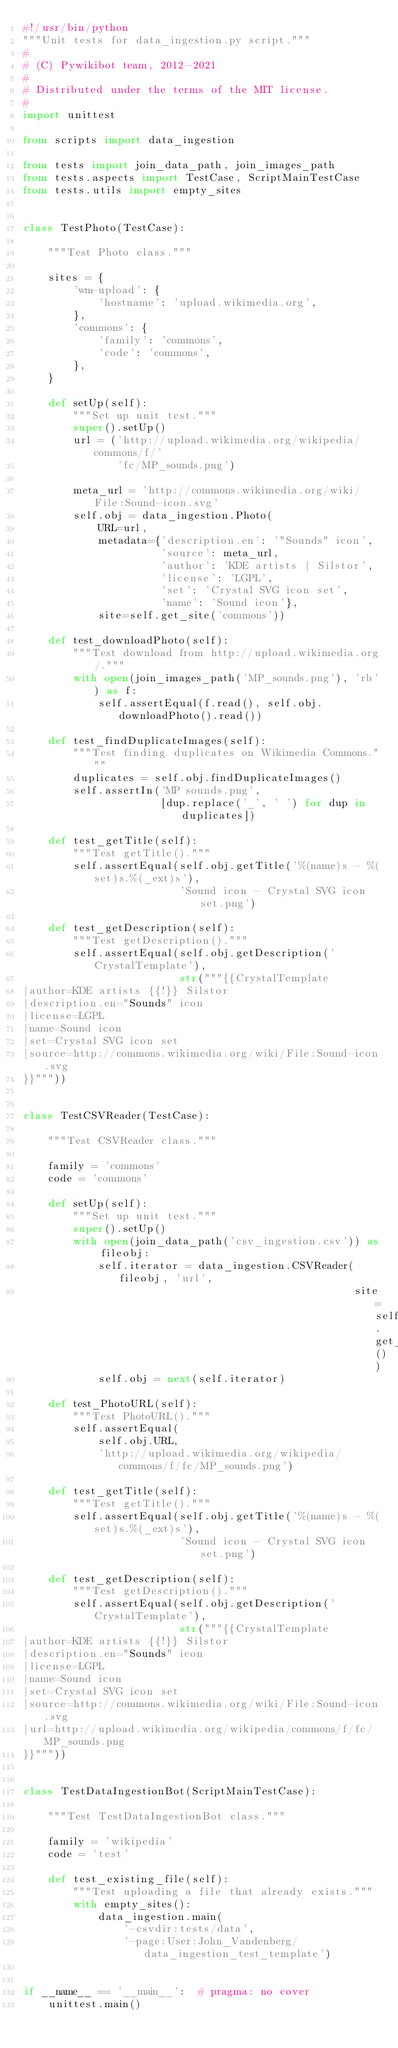Convert code to text. <code><loc_0><loc_0><loc_500><loc_500><_Python_>#!/usr/bin/python
"""Unit tests for data_ingestion.py script."""
#
# (C) Pywikibot team, 2012-2021
#
# Distributed under the terms of the MIT license.
#
import unittest

from scripts import data_ingestion

from tests import join_data_path, join_images_path
from tests.aspects import TestCase, ScriptMainTestCase
from tests.utils import empty_sites


class TestPhoto(TestCase):

    """Test Photo class."""

    sites = {
        'wm-upload': {
            'hostname': 'upload.wikimedia.org',
        },
        'commons': {
            'family': 'commons',
            'code': 'commons',
        },
    }

    def setUp(self):
        """Set up unit test."""
        super().setUp()
        url = ('http://upload.wikimedia.org/wikipedia/commons/f/'
               'fc/MP_sounds.png')

        meta_url = 'http://commons.wikimedia.org/wiki/File:Sound-icon.svg'
        self.obj = data_ingestion.Photo(
            URL=url,
            metadata={'description.en': '"Sounds" icon',
                      'source': meta_url,
                      'author': 'KDE artists | Silstor',
                      'license': 'LGPL',
                      'set': 'Crystal SVG icon set',
                      'name': 'Sound icon'},
            site=self.get_site('commons'))

    def test_downloadPhoto(self):
        """Test download from http://upload.wikimedia.org/."""
        with open(join_images_path('MP_sounds.png'), 'rb') as f:
            self.assertEqual(f.read(), self.obj.downloadPhoto().read())

    def test_findDuplicateImages(self):
        """Test finding duplicates on Wikimedia Commons."""
        duplicates = self.obj.findDuplicateImages()
        self.assertIn('MP sounds.png',
                      [dup.replace('_', ' ') for dup in duplicates])

    def test_getTitle(self):
        """Test getTitle()."""
        self.assertEqual(self.obj.getTitle('%(name)s - %(set)s.%(_ext)s'),
                         'Sound icon - Crystal SVG icon set.png')

    def test_getDescription(self):
        """Test getDescription()."""
        self.assertEqual(self.obj.getDescription('CrystalTemplate'),
                         str("""{{CrystalTemplate
|author=KDE artists {{!}} Silstor
|description.en="Sounds" icon
|license=LGPL
|name=Sound icon
|set=Crystal SVG icon set
|source=http://commons.wikimedia.org/wiki/File:Sound-icon.svg
}}"""))


class TestCSVReader(TestCase):

    """Test CSVReader class."""

    family = 'commons'
    code = 'commons'

    def setUp(self):
        """Set up unit test."""
        super().setUp()
        with open(join_data_path('csv_ingestion.csv')) as fileobj:
            self.iterator = data_ingestion.CSVReader(fileobj, 'url',
                                                     site=self.get_site())
            self.obj = next(self.iterator)

    def test_PhotoURL(self):
        """Test PhotoURL()."""
        self.assertEqual(
            self.obj.URL,
            'http://upload.wikimedia.org/wikipedia/commons/f/fc/MP_sounds.png')

    def test_getTitle(self):
        """Test getTitle()."""
        self.assertEqual(self.obj.getTitle('%(name)s - %(set)s.%(_ext)s'),
                         'Sound icon - Crystal SVG icon set.png')

    def test_getDescription(self):
        """Test getDescription()."""
        self.assertEqual(self.obj.getDescription('CrystalTemplate'),
                         str("""{{CrystalTemplate
|author=KDE artists {{!}} Silstor
|description.en="Sounds" icon
|license=LGPL
|name=Sound icon
|set=Crystal SVG icon set
|source=http://commons.wikimedia.org/wiki/File:Sound-icon.svg
|url=http://upload.wikimedia.org/wikipedia/commons/f/fc/MP_sounds.png
}}"""))


class TestDataIngestionBot(ScriptMainTestCase):

    """Test TestDataIngestionBot class."""

    family = 'wikipedia'
    code = 'test'

    def test_existing_file(self):
        """Test uploading a file that already exists."""
        with empty_sites():
            data_ingestion.main(
                '-csvdir:tests/data',
                '-page:User:John_Vandenberg/data_ingestion_test_template')


if __name__ == '__main__':  # pragma: no cover
    unittest.main()
</code> 